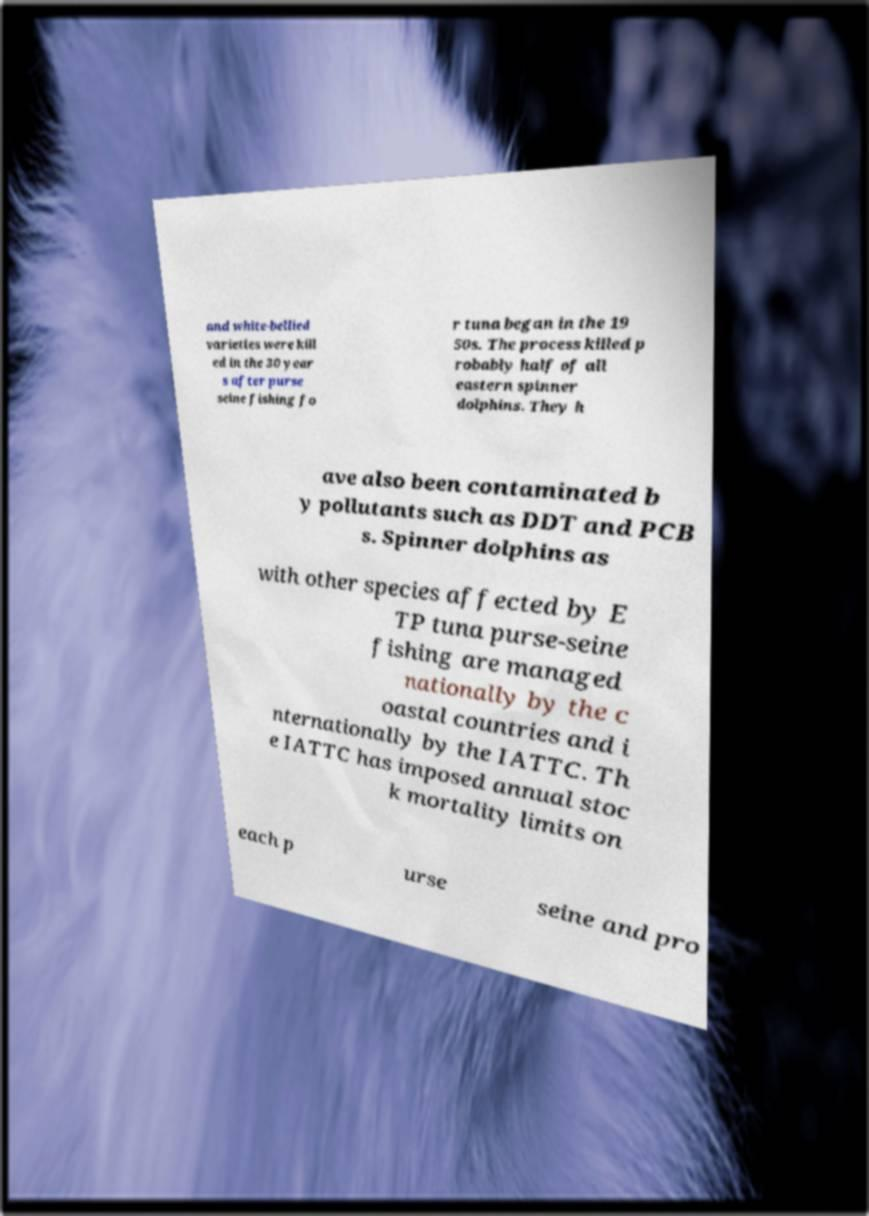I need the written content from this picture converted into text. Can you do that? and white-bellied varieties were kill ed in the 30 year s after purse seine fishing fo r tuna began in the 19 50s. The process killed p robably half of all eastern spinner dolphins. They h ave also been contaminated b y pollutants such as DDT and PCB s. Spinner dolphins as with other species affected by E TP tuna purse-seine fishing are managed nationally by the c oastal countries and i nternationally by the IATTC. Th e IATTC has imposed annual stoc k mortality limits on each p urse seine and pro 